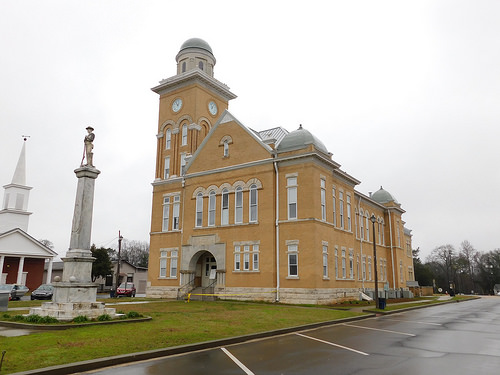<image>
Is the statue behind the car? No. The statue is not behind the car. From this viewpoint, the statue appears to be positioned elsewhere in the scene. Is there a steeple in front of the statue? No. The steeple is not in front of the statue. The spatial positioning shows a different relationship between these objects. 